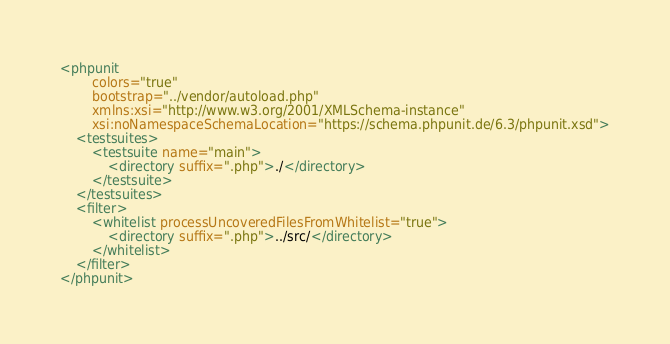<code> <loc_0><loc_0><loc_500><loc_500><_XML_><phpunit
        colors="true"
        bootstrap="../vendor/autoload.php"
        xmlns:xsi="http://www.w3.org/2001/XMLSchema-instance"
        xsi:noNamespaceSchemaLocation="https://schema.phpunit.de/6.3/phpunit.xsd">
    <testsuites>
        <testsuite name="main">
            <directory suffix=".php">./</directory>
        </testsuite>
    </testsuites>
    <filter>
        <whitelist processUncoveredFilesFromWhitelist="true">
            <directory suffix=".php">../src/</directory>
        </whitelist>
    </filter>
</phpunit>
</code> 